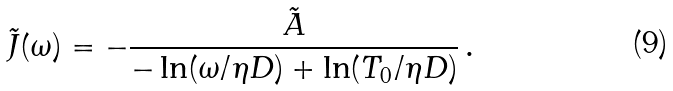Convert formula to latex. <formula><loc_0><loc_0><loc_500><loc_500>\tilde { J } ( \omega ) = - \frac { \tilde { A } } { - \ln ( \omega / \eta D ) + \ln ( T _ { 0 } / \eta D ) } \, .</formula> 